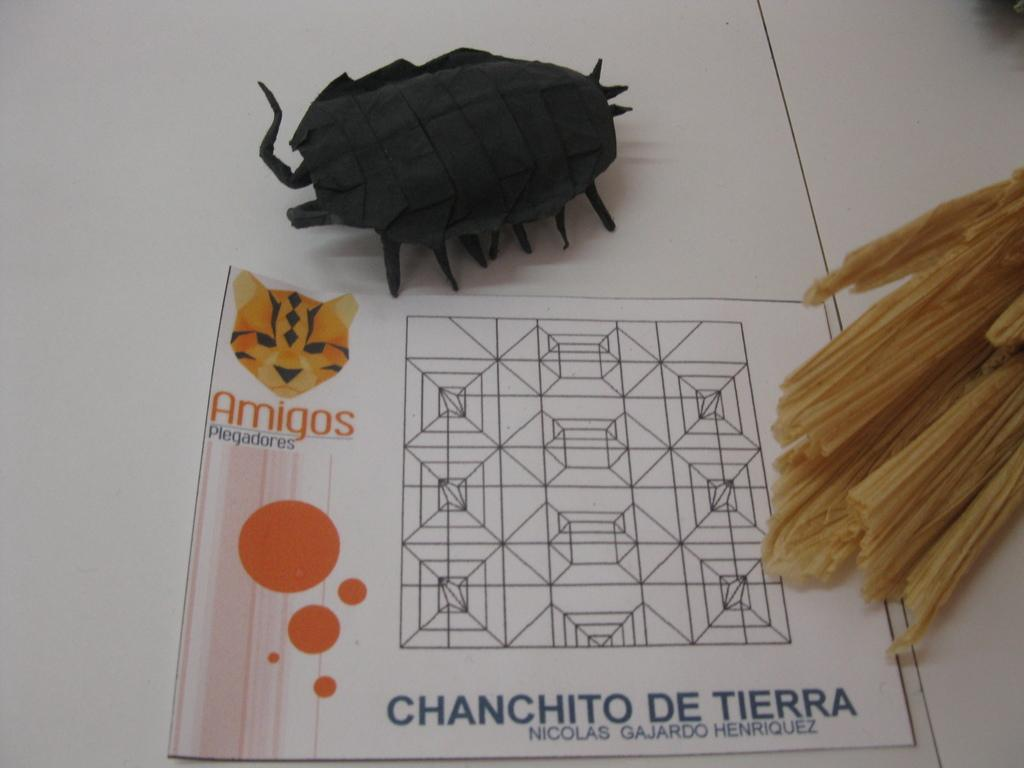What is the primary color of the surface in the image? The primary color of the surface in the image is white. What is placed on the white surface? There is a white paper with drawings on it. What type of object can be seen on the white paper? There is an artificial bug in the image. What type of flesh can be seen in the image? There is no flesh present in the image; it features a white surface, a white paper with drawings, and an artificial bug. 